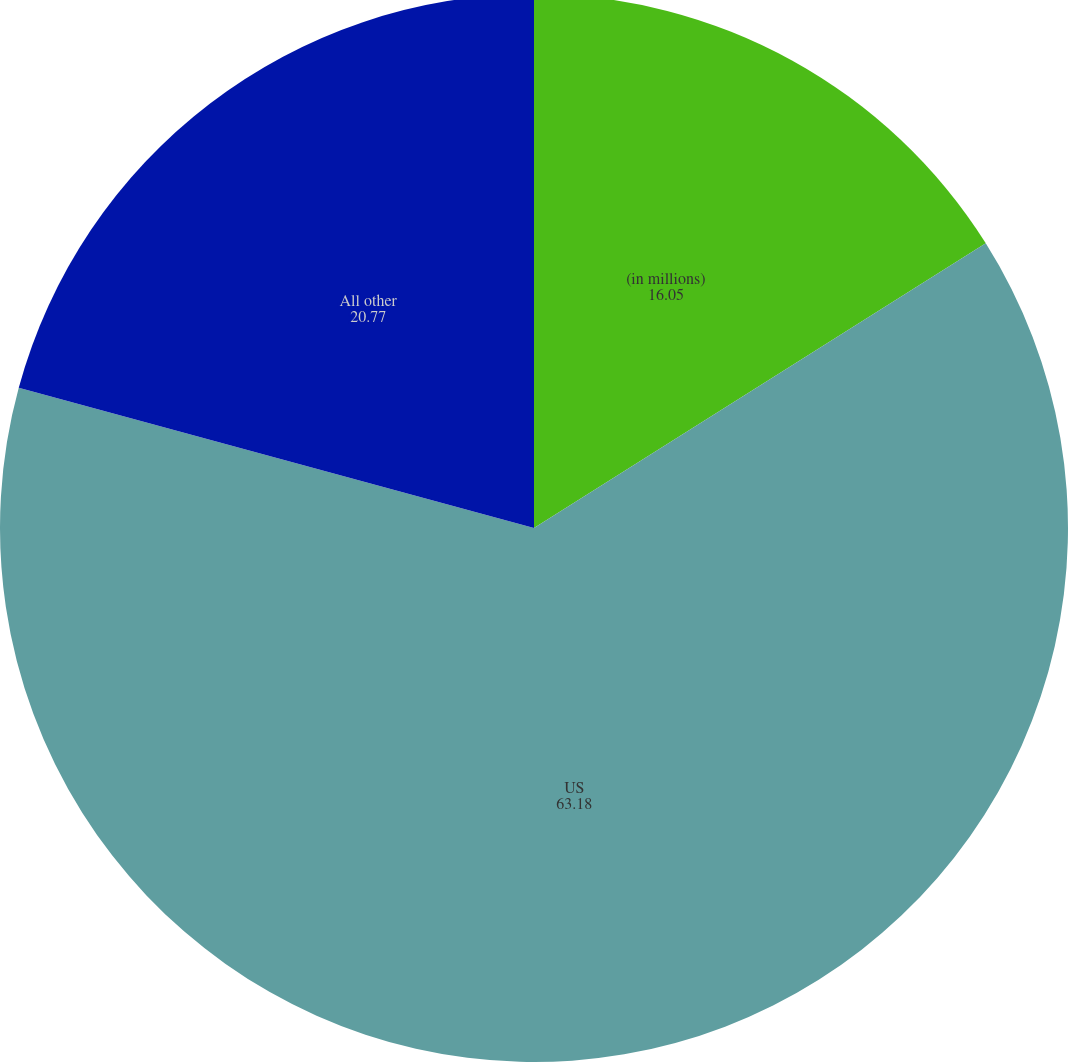Convert chart. <chart><loc_0><loc_0><loc_500><loc_500><pie_chart><fcel>(in millions)<fcel>US<fcel>All other<nl><fcel>16.05%<fcel>63.18%<fcel>20.77%<nl></chart> 